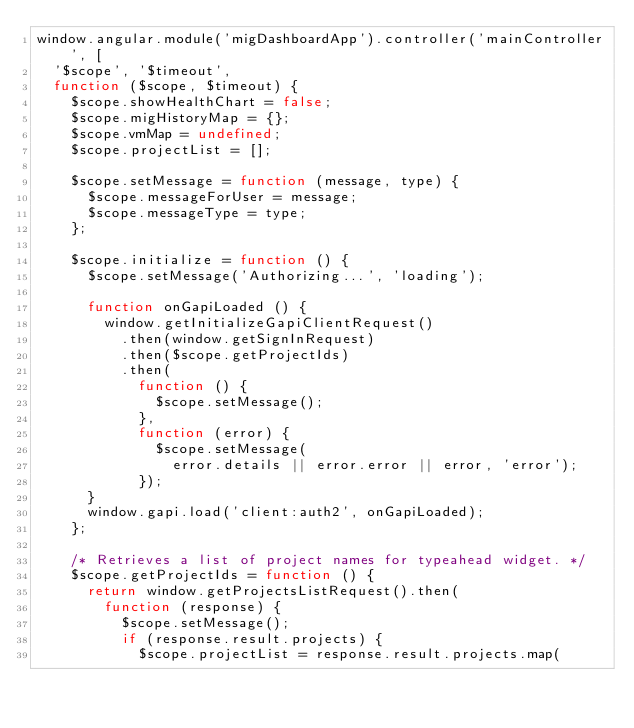Convert code to text. <code><loc_0><loc_0><loc_500><loc_500><_JavaScript_>window.angular.module('migDashboardApp').controller('mainController', [
  '$scope', '$timeout',
  function ($scope, $timeout) {
    $scope.showHealthChart = false;
    $scope.migHistoryMap = {};
    $scope.vmMap = undefined;
    $scope.projectList = [];

    $scope.setMessage = function (message, type) {
      $scope.messageForUser = message;
      $scope.messageType = type;
    };

    $scope.initialize = function () {
      $scope.setMessage('Authorizing...', 'loading');

      function onGapiLoaded () {
        window.getInitializeGapiClientRequest()
          .then(window.getSignInRequest)
          .then($scope.getProjectIds)
          .then(
            function () {
              $scope.setMessage();
            },
            function (error) {
              $scope.setMessage(
                error.details || error.error || error, 'error');
            });
      }
      window.gapi.load('client:auth2', onGapiLoaded);
    };

    /* Retrieves a list of project names for typeahead widget. */
    $scope.getProjectIds = function () {
      return window.getProjectsListRequest().then(
        function (response) {
          $scope.setMessage();
          if (response.result.projects) {
            $scope.projectList = response.result.projects.map(</code> 